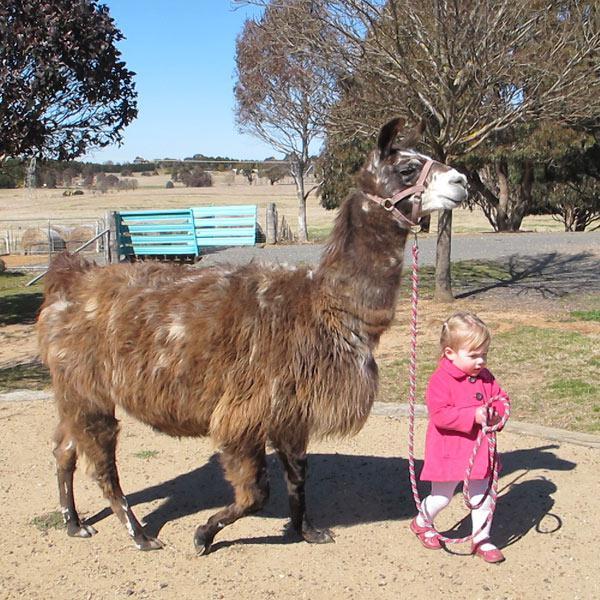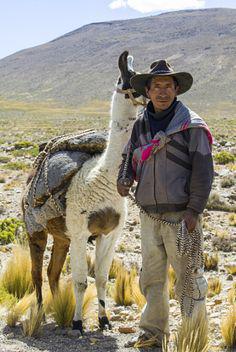The first image is the image on the left, the second image is the image on the right. Considering the images on both sides, is "Something is wearing pink." valid? Answer yes or no. Yes. The first image is the image on the left, the second image is the image on the right. Analyze the images presented: Is the assertion "At least one person can be seen holding reins." valid? Answer yes or no. Yes. 